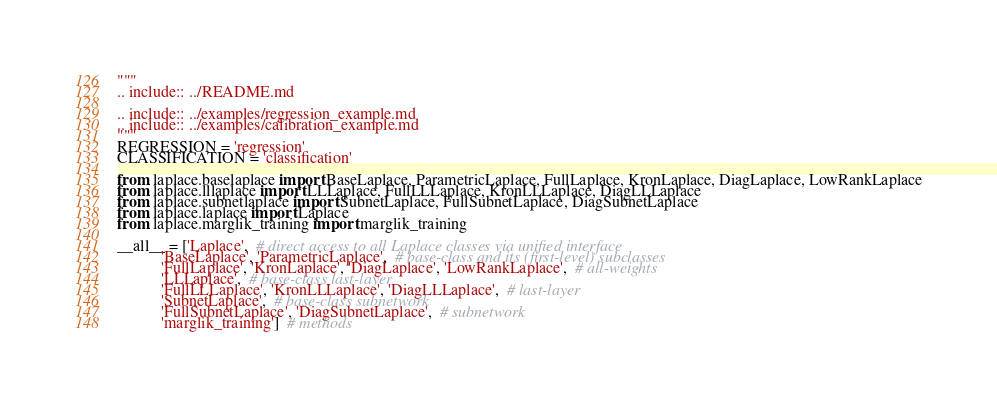Convert code to text. <code><loc_0><loc_0><loc_500><loc_500><_Python_>"""
.. include:: ../README.md

.. include:: ../examples/regression_example.md
.. include:: ../examples/calibration_example.md
"""
REGRESSION = 'regression'
CLASSIFICATION = 'classification'

from laplace.baselaplace import BaseLaplace, ParametricLaplace, FullLaplace, KronLaplace, DiagLaplace, LowRankLaplace
from laplace.lllaplace import LLLaplace, FullLLLaplace, KronLLLaplace, DiagLLLaplace
from laplace.subnetlaplace import SubnetLaplace, FullSubnetLaplace, DiagSubnetLaplace
from laplace.laplace import Laplace
from laplace.marglik_training import marglik_training

__all__ = ['Laplace',  # direct access to all Laplace classes via unified interface
           'BaseLaplace', 'ParametricLaplace',  # base-class and its (first-level) subclasses
           'FullLaplace', 'KronLaplace', 'DiagLaplace', 'LowRankLaplace',  # all-weights
           'LLLaplace',  # base-class last-layer
           'FullLLLaplace', 'KronLLLaplace', 'DiagLLLaplace',  # last-layer
           'SubnetLaplace',  # base-class subnetwork
           'FullSubnetLaplace', 'DiagSubnetLaplace',  # subnetwork
           'marglik_training']  # methods
</code> 